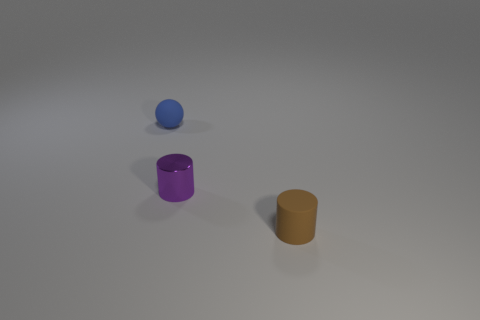Add 1 small rubber cylinders. How many objects exist? 4 Subtract all spheres. How many objects are left? 2 Subtract all small gray metal balls. Subtract all small brown matte cylinders. How many objects are left? 2 Add 2 small rubber cylinders. How many small rubber cylinders are left? 3 Add 2 blue things. How many blue things exist? 3 Subtract 0 purple balls. How many objects are left? 3 